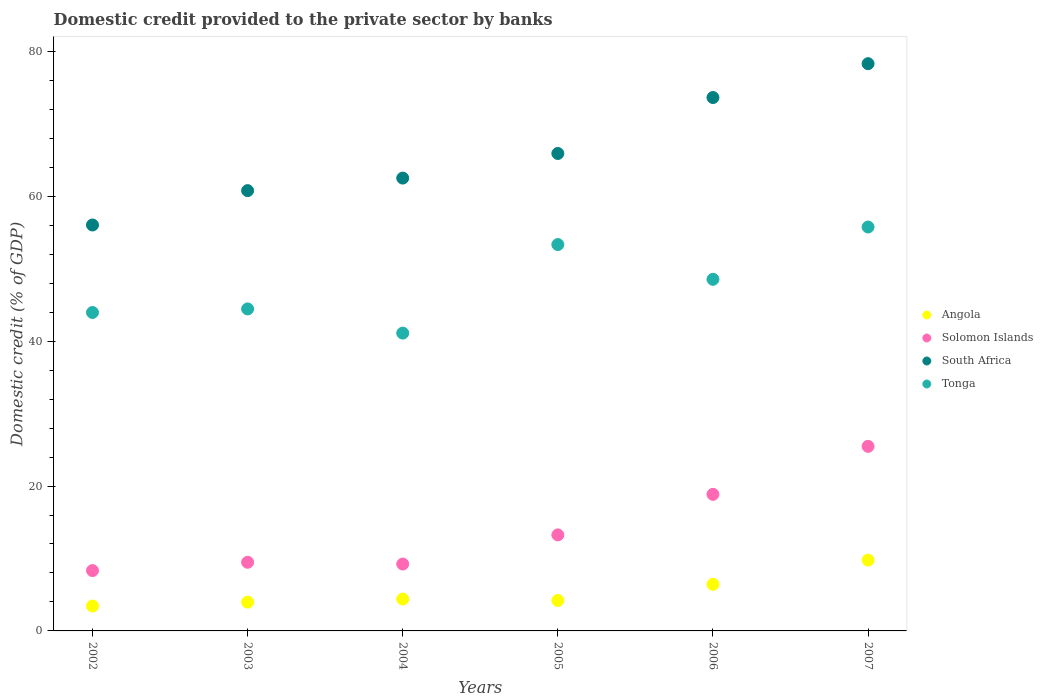Is the number of dotlines equal to the number of legend labels?
Keep it short and to the point. Yes. What is the domestic credit provided to the private sector by banks in Tonga in 2002?
Ensure brevity in your answer.  43.95. Across all years, what is the maximum domestic credit provided to the private sector by banks in Angola?
Offer a very short reply. 9.77. Across all years, what is the minimum domestic credit provided to the private sector by banks in Tonga?
Your answer should be compact. 41.11. In which year was the domestic credit provided to the private sector by banks in Angola minimum?
Offer a terse response. 2002. What is the total domestic credit provided to the private sector by banks in Solomon Islands in the graph?
Give a very brief answer. 84.62. What is the difference between the domestic credit provided to the private sector by banks in South Africa in 2006 and that in 2007?
Offer a very short reply. -4.67. What is the difference between the domestic credit provided to the private sector by banks in Angola in 2004 and the domestic credit provided to the private sector by banks in South Africa in 2005?
Offer a terse response. -61.5. What is the average domestic credit provided to the private sector by banks in Angola per year?
Your answer should be very brief. 5.37. In the year 2002, what is the difference between the domestic credit provided to the private sector by banks in Solomon Islands and domestic credit provided to the private sector by banks in Angola?
Your answer should be very brief. 4.89. What is the ratio of the domestic credit provided to the private sector by banks in Angola in 2004 to that in 2007?
Keep it short and to the point. 0.45. Is the difference between the domestic credit provided to the private sector by banks in Solomon Islands in 2002 and 2005 greater than the difference between the domestic credit provided to the private sector by banks in Angola in 2002 and 2005?
Give a very brief answer. No. What is the difference between the highest and the second highest domestic credit provided to the private sector by banks in South Africa?
Keep it short and to the point. 4.67. What is the difference between the highest and the lowest domestic credit provided to the private sector by banks in South Africa?
Your answer should be very brief. 22.26. In how many years, is the domestic credit provided to the private sector by banks in South Africa greater than the average domestic credit provided to the private sector by banks in South Africa taken over all years?
Offer a terse response. 2. Is the sum of the domestic credit provided to the private sector by banks in South Africa in 2005 and 2007 greater than the maximum domestic credit provided to the private sector by banks in Tonga across all years?
Keep it short and to the point. Yes. Is it the case that in every year, the sum of the domestic credit provided to the private sector by banks in Tonga and domestic credit provided to the private sector by banks in South Africa  is greater than the domestic credit provided to the private sector by banks in Solomon Islands?
Your response must be concise. Yes. Does the domestic credit provided to the private sector by banks in South Africa monotonically increase over the years?
Your answer should be compact. Yes. Is the domestic credit provided to the private sector by banks in Solomon Islands strictly greater than the domestic credit provided to the private sector by banks in Tonga over the years?
Provide a short and direct response. No. How many dotlines are there?
Provide a succinct answer. 4. Does the graph contain any zero values?
Give a very brief answer. No. Does the graph contain grids?
Your answer should be very brief. No. How many legend labels are there?
Offer a very short reply. 4. How are the legend labels stacked?
Provide a succinct answer. Vertical. What is the title of the graph?
Ensure brevity in your answer.  Domestic credit provided to the private sector by banks. What is the label or title of the Y-axis?
Keep it short and to the point. Domestic credit (% of GDP). What is the Domestic credit (% of GDP) of Angola in 2002?
Keep it short and to the point. 3.44. What is the Domestic credit (% of GDP) of Solomon Islands in 2002?
Provide a short and direct response. 8.33. What is the Domestic credit (% of GDP) of South Africa in 2002?
Offer a very short reply. 56.03. What is the Domestic credit (% of GDP) in Tonga in 2002?
Give a very brief answer. 43.95. What is the Domestic credit (% of GDP) in Angola in 2003?
Provide a succinct answer. 3.98. What is the Domestic credit (% of GDP) in Solomon Islands in 2003?
Your response must be concise. 9.48. What is the Domestic credit (% of GDP) of South Africa in 2003?
Your response must be concise. 60.77. What is the Domestic credit (% of GDP) of Tonga in 2003?
Offer a terse response. 44.44. What is the Domestic credit (% of GDP) in Angola in 2004?
Ensure brevity in your answer.  4.4. What is the Domestic credit (% of GDP) of Solomon Islands in 2004?
Offer a terse response. 9.23. What is the Domestic credit (% of GDP) in South Africa in 2004?
Offer a terse response. 62.5. What is the Domestic credit (% of GDP) of Tonga in 2004?
Your answer should be very brief. 41.11. What is the Domestic credit (% of GDP) of Angola in 2005?
Keep it short and to the point. 4.2. What is the Domestic credit (% of GDP) in Solomon Islands in 2005?
Provide a succinct answer. 13.25. What is the Domestic credit (% of GDP) of South Africa in 2005?
Give a very brief answer. 65.9. What is the Domestic credit (% of GDP) in Tonga in 2005?
Give a very brief answer. 53.33. What is the Domestic credit (% of GDP) in Angola in 2006?
Your answer should be compact. 6.43. What is the Domestic credit (% of GDP) in Solomon Islands in 2006?
Your answer should be compact. 18.85. What is the Domestic credit (% of GDP) of South Africa in 2006?
Your answer should be compact. 73.62. What is the Domestic credit (% of GDP) in Tonga in 2006?
Provide a short and direct response. 48.53. What is the Domestic credit (% of GDP) in Angola in 2007?
Your answer should be compact. 9.77. What is the Domestic credit (% of GDP) in Solomon Islands in 2007?
Your answer should be compact. 25.48. What is the Domestic credit (% of GDP) in South Africa in 2007?
Offer a very short reply. 78.29. What is the Domestic credit (% of GDP) in Tonga in 2007?
Provide a succinct answer. 55.75. Across all years, what is the maximum Domestic credit (% of GDP) of Angola?
Provide a short and direct response. 9.77. Across all years, what is the maximum Domestic credit (% of GDP) of Solomon Islands?
Provide a succinct answer. 25.48. Across all years, what is the maximum Domestic credit (% of GDP) of South Africa?
Your response must be concise. 78.29. Across all years, what is the maximum Domestic credit (% of GDP) of Tonga?
Keep it short and to the point. 55.75. Across all years, what is the minimum Domestic credit (% of GDP) in Angola?
Ensure brevity in your answer.  3.44. Across all years, what is the minimum Domestic credit (% of GDP) in Solomon Islands?
Offer a terse response. 8.33. Across all years, what is the minimum Domestic credit (% of GDP) in South Africa?
Ensure brevity in your answer.  56.03. Across all years, what is the minimum Domestic credit (% of GDP) of Tonga?
Keep it short and to the point. 41.11. What is the total Domestic credit (% of GDP) in Angola in the graph?
Keep it short and to the point. 32.21. What is the total Domestic credit (% of GDP) in Solomon Islands in the graph?
Keep it short and to the point. 84.62. What is the total Domestic credit (% of GDP) of South Africa in the graph?
Provide a short and direct response. 397.13. What is the total Domestic credit (% of GDP) of Tonga in the graph?
Your response must be concise. 287.11. What is the difference between the Domestic credit (% of GDP) of Angola in 2002 and that in 2003?
Offer a terse response. -0.54. What is the difference between the Domestic credit (% of GDP) of Solomon Islands in 2002 and that in 2003?
Your answer should be very brief. -1.15. What is the difference between the Domestic credit (% of GDP) in South Africa in 2002 and that in 2003?
Make the answer very short. -4.74. What is the difference between the Domestic credit (% of GDP) of Tonga in 2002 and that in 2003?
Provide a succinct answer. -0.49. What is the difference between the Domestic credit (% of GDP) of Angola in 2002 and that in 2004?
Your response must be concise. -0.96. What is the difference between the Domestic credit (% of GDP) of Solomon Islands in 2002 and that in 2004?
Ensure brevity in your answer.  -0.9. What is the difference between the Domestic credit (% of GDP) in South Africa in 2002 and that in 2004?
Your response must be concise. -6.47. What is the difference between the Domestic credit (% of GDP) of Tonga in 2002 and that in 2004?
Keep it short and to the point. 2.85. What is the difference between the Domestic credit (% of GDP) in Angola in 2002 and that in 2005?
Your answer should be very brief. -0.77. What is the difference between the Domestic credit (% of GDP) in Solomon Islands in 2002 and that in 2005?
Ensure brevity in your answer.  -4.93. What is the difference between the Domestic credit (% of GDP) in South Africa in 2002 and that in 2005?
Your answer should be very brief. -9.87. What is the difference between the Domestic credit (% of GDP) in Tonga in 2002 and that in 2005?
Offer a very short reply. -9.38. What is the difference between the Domestic credit (% of GDP) of Angola in 2002 and that in 2006?
Give a very brief answer. -2.99. What is the difference between the Domestic credit (% of GDP) of Solomon Islands in 2002 and that in 2006?
Your answer should be very brief. -10.52. What is the difference between the Domestic credit (% of GDP) in South Africa in 2002 and that in 2006?
Ensure brevity in your answer.  -17.59. What is the difference between the Domestic credit (% of GDP) in Tonga in 2002 and that in 2006?
Your answer should be compact. -4.58. What is the difference between the Domestic credit (% of GDP) of Angola in 2002 and that in 2007?
Offer a terse response. -6.34. What is the difference between the Domestic credit (% of GDP) in Solomon Islands in 2002 and that in 2007?
Offer a terse response. -17.15. What is the difference between the Domestic credit (% of GDP) of South Africa in 2002 and that in 2007?
Ensure brevity in your answer.  -22.26. What is the difference between the Domestic credit (% of GDP) in Tonga in 2002 and that in 2007?
Offer a terse response. -11.8. What is the difference between the Domestic credit (% of GDP) of Angola in 2003 and that in 2004?
Offer a very short reply. -0.42. What is the difference between the Domestic credit (% of GDP) of Solomon Islands in 2003 and that in 2004?
Your answer should be compact. 0.25. What is the difference between the Domestic credit (% of GDP) of South Africa in 2003 and that in 2004?
Provide a succinct answer. -1.73. What is the difference between the Domestic credit (% of GDP) of Tonga in 2003 and that in 2004?
Offer a very short reply. 3.34. What is the difference between the Domestic credit (% of GDP) in Angola in 2003 and that in 2005?
Your answer should be very brief. -0.23. What is the difference between the Domestic credit (% of GDP) in Solomon Islands in 2003 and that in 2005?
Ensure brevity in your answer.  -3.78. What is the difference between the Domestic credit (% of GDP) of South Africa in 2003 and that in 2005?
Provide a succinct answer. -5.13. What is the difference between the Domestic credit (% of GDP) of Tonga in 2003 and that in 2005?
Offer a terse response. -8.88. What is the difference between the Domestic credit (% of GDP) in Angola in 2003 and that in 2006?
Ensure brevity in your answer.  -2.45. What is the difference between the Domestic credit (% of GDP) of Solomon Islands in 2003 and that in 2006?
Give a very brief answer. -9.37. What is the difference between the Domestic credit (% of GDP) of South Africa in 2003 and that in 2006?
Ensure brevity in your answer.  -12.85. What is the difference between the Domestic credit (% of GDP) of Tonga in 2003 and that in 2006?
Offer a very short reply. -4.09. What is the difference between the Domestic credit (% of GDP) in Angola in 2003 and that in 2007?
Provide a short and direct response. -5.8. What is the difference between the Domestic credit (% of GDP) in Solomon Islands in 2003 and that in 2007?
Make the answer very short. -16. What is the difference between the Domestic credit (% of GDP) in South Africa in 2003 and that in 2007?
Offer a terse response. -17.52. What is the difference between the Domestic credit (% of GDP) in Tonga in 2003 and that in 2007?
Provide a short and direct response. -11.31. What is the difference between the Domestic credit (% of GDP) of Angola in 2004 and that in 2005?
Your response must be concise. 0.2. What is the difference between the Domestic credit (% of GDP) in Solomon Islands in 2004 and that in 2005?
Keep it short and to the point. -4.02. What is the difference between the Domestic credit (% of GDP) of South Africa in 2004 and that in 2005?
Offer a very short reply. -3.4. What is the difference between the Domestic credit (% of GDP) of Tonga in 2004 and that in 2005?
Give a very brief answer. -12.22. What is the difference between the Domestic credit (% of GDP) of Angola in 2004 and that in 2006?
Give a very brief answer. -2.03. What is the difference between the Domestic credit (% of GDP) of Solomon Islands in 2004 and that in 2006?
Give a very brief answer. -9.62. What is the difference between the Domestic credit (% of GDP) of South Africa in 2004 and that in 2006?
Your answer should be very brief. -11.12. What is the difference between the Domestic credit (% of GDP) in Tonga in 2004 and that in 2006?
Offer a terse response. -7.42. What is the difference between the Domestic credit (% of GDP) in Angola in 2004 and that in 2007?
Make the answer very short. -5.38. What is the difference between the Domestic credit (% of GDP) of Solomon Islands in 2004 and that in 2007?
Provide a succinct answer. -16.25. What is the difference between the Domestic credit (% of GDP) in South Africa in 2004 and that in 2007?
Offer a very short reply. -15.79. What is the difference between the Domestic credit (% of GDP) in Tonga in 2004 and that in 2007?
Make the answer very short. -14.64. What is the difference between the Domestic credit (% of GDP) in Angola in 2005 and that in 2006?
Keep it short and to the point. -2.22. What is the difference between the Domestic credit (% of GDP) in Solomon Islands in 2005 and that in 2006?
Your response must be concise. -5.6. What is the difference between the Domestic credit (% of GDP) of South Africa in 2005 and that in 2006?
Your response must be concise. -7.72. What is the difference between the Domestic credit (% of GDP) of Tonga in 2005 and that in 2006?
Provide a short and direct response. 4.8. What is the difference between the Domestic credit (% of GDP) in Angola in 2005 and that in 2007?
Give a very brief answer. -5.57. What is the difference between the Domestic credit (% of GDP) of Solomon Islands in 2005 and that in 2007?
Provide a short and direct response. -12.22. What is the difference between the Domestic credit (% of GDP) of South Africa in 2005 and that in 2007?
Offer a terse response. -12.39. What is the difference between the Domestic credit (% of GDP) in Tonga in 2005 and that in 2007?
Keep it short and to the point. -2.42. What is the difference between the Domestic credit (% of GDP) in Angola in 2006 and that in 2007?
Provide a succinct answer. -3.35. What is the difference between the Domestic credit (% of GDP) of Solomon Islands in 2006 and that in 2007?
Your response must be concise. -6.63. What is the difference between the Domestic credit (% of GDP) of South Africa in 2006 and that in 2007?
Your answer should be compact. -4.67. What is the difference between the Domestic credit (% of GDP) of Tonga in 2006 and that in 2007?
Keep it short and to the point. -7.22. What is the difference between the Domestic credit (% of GDP) of Angola in 2002 and the Domestic credit (% of GDP) of Solomon Islands in 2003?
Your response must be concise. -6.04. What is the difference between the Domestic credit (% of GDP) in Angola in 2002 and the Domestic credit (% of GDP) in South Africa in 2003?
Provide a succinct answer. -57.34. What is the difference between the Domestic credit (% of GDP) of Angola in 2002 and the Domestic credit (% of GDP) of Tonga in 2003?
Make the answer very short. -41.01. What is the difference between the Domestic credit (% of GDP) in Solomon Islands in 2002 and the Domestic credit (% of GDP) in South Africa in 2003?
Keep it short and to the point. -52.44. What is the difference between the Domestic credit (% of GDP) in Solomon Islands in 2002 and the Domestic credit (% of GDP) in Tonga in 2003?
Keep it short and to the point. -36.12. What is the difference between the Domestic credit (% of GDP) in South Africa in 2002 and the Domestic credit (% of GDP) in Tonga in 2003?
Provide a succinct answer. 11.59. What is the difference between the Domestic credit (% of GDP) of Angola in 2002 and the Domestic credit (% of GDP) of Solomon Islands in 2004?
Provide a succinct answer. -5.8. What is the difference between the Domestic credit (% of GDP) in Angola in 2002 and the Domestic credit (% of GDP) in South Africa in 2004?
Offer a very short reply. -59.07. What is the difference between the Domestic credit (% of GDP) in Angola in 2002 and the Domestic credit (% of GDP) in Tonga in 2004?
Give a very brief answer. -37.67. What is the difference between the Domestic credit (% of GDP) in Solomon Islands in 2002 and the Domestic credit (% of GDP) in South Africa in 2004?
Offer a very short reply. -54.18. What is the difference between the Domestic credit (% of GDP) of Solomon Islands in 2002 and the Domestic credit (% of GDP) of Tonga in 2004?
Give a very brief answer. -32.78. What is the difference between the Domestic credit (% of GDP) in South Africa in 2002 and the Domestic credit (% of GDP) in Tonga in 2004?
Ensure brevity in your answer.  14.92. What is the difference between the Domestic credit (% of GDP) in Angola in 2002 and the Domestic credit (% of GDP) in Solomon Islands in 2005?
Offer a terse response. -9.82. What is the difference between the Domestic credit (% of GDP) of Angola in 2002 and the Domestic credit (% of GDP) of South Africa in 2005?
Give a very brief answer. -62.47. What is the difference between the Domestic credit (% of GDP) in Angola in 2002 and the Domestic credit (% of GDP) in Tonga in 2005?
Offer a very short reply. -49.89. What is the difference between the Domestic credit (% of GDP) of Solomon Islands in 2002 and the Domestic credit (% of GDP) of South Africa in 2005?
Your response must be concise. -57.57. What is the difference between the Domestic credit (% of GDP) in Solomon Islands in 2002 and the Domestic credit (% of GDP) in Tonga in 2005?
Offer a terse response. -45. What is the difference between the Domestic credit (% of GDP) of South Africa in 2002 and the Domestic credit (% of GDP) of Tonga in 2005?
Your answer should be very brief. 2.7. What is the difference between the Domestic credit (% of GDP) of Angola in 2002 and the Domestic credit (% of GDP) of Solomon Islands in 2006?
Keep it short and to the point. -15.42. What is the difference between the Domestic credit (% of GDP) in Angola in 2002 and the Domestic credit (% of GDP) in South Africa in 2006?
Your answer should be compact. -70.19. What is the difference between the Domestic credit (% of GDP) of Angola in 2002 and the Domestic credit (% of GDP) of Tonga in 2006?
Offer a very short reply. -45.1. What is the difference between the Domestic credit (% of GDP) in Solomon Islands in 2002 and the Domestic credit (% of GDP) in South Africa in 2006?
Ensure brevity in your answer.  -65.3. What is the difference between the Domestic credit (% of GDP) of Solomon Islands in 2002 and the Domestic credit (% of GDP) of Tonga in 2006?
Provide a short and direct response. -40.2. What is the difference between the Domestic credit (% of GDP) of South Africa in 2002 and the Domestic credit (% of GDP) of Tonga in 2006?
Give a very brief answer. 7.5. What is the difference between the Domestic credit (% of GDP) of Angola in 2002 and the Domestic credit (% of GDP) of Solomon Islands in 2007?
Your response must be concise. -22.04. What is the difference between the Domestic credit (% of GDP) of Angola in 2002 and the Domestic credit (% of GDP) of South Africa in 2007?
Your answer should be compact. -74.86. What is the difference between the Domestic credit (% of GDP) in Angola in 2002 and the Domestic credit (% of GDP) in Tonga in 2007?
Give a very brief answer. -52.32. What is the difference between the Domestic credit (% of GDP) in Solomon Islands in 2002 and the Domestic credit (% of GDP) in South Africa in 2007?
Your answer should be very brief. -69.97. What is the difference between the Domestic credit (% of GDP) of Solomon Islands in 2002 and the Domestic credit (% of GDP) of Tonga in 2007?
Your answer should be very brief. -47.42. What is the difference between the Domestic credit (% of GDP) of South Africa in 2002 and the Domestic credit (% of GDP) of Tonga in 2007?
Ensure brevity in your answer.  0.28. What is the difference between the Domestic credit (% of GDP) in Angola in 2003 and the Domestic credit (% of GDP) in Solomon Islands in 2004?
Your answer should be compact. -5.26. What is the difference between the Domestic credit (% of GDP) in Angola in 2003 and the Domestic credit (% of GDP) in South Africa in 2004?
Your answer should be compact. -58.53. What is the difference between the Domestic credit (% of GDP) in Angola in 2003 and the Domestic credit (% of GDP) in Tonga in 2004?
Offer a very short reply. -37.13. What is the difference between the Domestic credit (% of GDP) in Solomon Islands in 2003 and the Domestic credit (% of GDP) in South Africa in 2004?
Give a very brief answer. -53.03. What is the difference between the Domestic credit (% of GDP) in Solomon Islands in 2003 and the Domestic credit (% of GDP) in Tonga in 2004?
Your answer should be very brief. -31.63. What is the difference between the Domestic credit (% of GDP) in South Africa in 2003 and the Domestic credit (% of GDP) in Tonga in 2004?
Provide a succinct answer. 19.67. What is the difference between the Domestic credit (% of GDP) in Angola in 2003 and the Domestic credit (% of GDP) in Solomon Islands in 2005?
Ensure brevity in your answer.  -9.28. What is the difference between the Domestic credit (% of GDP) of Angola in 2003 and the Domestic credit (% of GDP) of South Africa in 2005?
Offer a very short reply. -61.93. What is the difference between the Domestic credit (% of GDP) of Angola in 2003 and the Domestic credit (% of GDP) of Tonga in 2005?
Provide a succinct answer. -49.35. What is the difference between the Domestic credit (% of GDP) of Solomon Islands in 2003 and the Domestic credit (% of GDP) of South Africa in 2005?
Ensure brevity in your answer.  -56.43. What is the difference between the Domestic credit (% of GDP) in Solomon Islands in 2003 and the Domestic credit (% of GDP) in Tonga in 2005?
Offer a terse response. -43.85. What is the difference between the Domestic credit (% of GDP) of South Africa in 2003 and the Domestic credit (% of GDP) of Tonga in 2005?
Provide a succinct answer. 7.44. What is the difference between the Domestic credit (% of GDP) in Angola in 2003 and the Domestic credit (% of GDP) in Solomon Islands in 2006?
Offer a terse response. -14.88. What is the difference between the Domestic credit (% of GDP) of Angola in 2003 and the Domestic credit (% of GDP) of South Africa in 2006?
Offer a very short reply. -69.65. What is the difference between the Domestic credit (% of GDP) of Angola in 2003 and the Domestic credit (% of GDP) of Tonga in 2006?
Offer a terse response. -44.55. What is the difference between the Domestic credit (% of GDP) in Solomon Islands in 2003 and the Domestic credit (% of GDP) in South Africa in 2006?
Offer a terse response. -64.15. What is the difference between the Domestic credit (% of GDP) in Solomon Islands in 2003 and the Domestic credit (% of GDP) in Tonga in 2006?
Provide a succinct answer. -39.05. What is the difference between the Domestic credit (% of GDP) in South Africa in 2003 and the Domestic credit (% of GDP) in Tonga in 2006?
Your answer should be very brief. 12.24. What is the difference between the Domestic credit (% of GDP) in Angola in 2003 and the Domestic credit (% of GDP) in Solomon Islands in 2007?
Offer a very short reply. -21.5. What is the difference between the Domestic credit (% of GDP) in Angola in 2003 and the Domestic credit (% of GDP) in South Africa in 2007?
Make the answer very short. -74.32. What is the difference between the Domestic credit (% of GDP) of Angola in 2003 and the Domestic credit (% of GDP) of Tonga in 2007?
Your answer should be very brief. -51.77. What is the difference between the Domestic credit (% of GDP) of Solomon Islands in 2003 and the Domestic credit (% of GDP) of South Africa in 2007?
Ensure brevity in your answer.  -68.82. What is the difference between the Domestic credit (% of GDP) in Solomon Islands in 2003 and the Domestic credit (% of GDP) in Tonga in 2007?
Provide a succinct answer. -46.27. What is the difference between the Domestic credit (% of GDP) in South Africa in 2003 and the Domestic credit (% of GDP) in Tonga in 2007?
Ensure brevity in your answer.  5.02. What is the difference between the Domestic credit (% of GDP) in Angola in 2004 and the Domestic credit (% of GDP) in Solomon Islands in 2005?
Your answer should be very brief. -8.86. What is the difference between the Domestic credit (% of GDP) of Angola in 2004 and the Domestic credit (% of GDP) of South Africa in 2005?
Provide a short and direct response. -61.5. What is the difference between the Domestic credit (% of GDP) in Angola in 2004 and the Domestic credit (% of GDP) in Tonga in 2005?
Give a very brief answer. -48.93. What is the difference between the Domestic credit (% of GDP) of Solomon Islands in 2004 and the Domestic credit (% of GDP) of South Africa in 2005?
Offer a terse response. -56.67. What is the difference between the Domestic credit (% of GDP) in Solomon Islands in 2004 and the Domestic credit (% of GDP) in Tonga in 2005?
Your answer should be very brief. -44.1. What is the difference between the Domestic credit (% of GDP) in South Africa in 2004 and the Domestic credit (% of GDP) in Tonga in 2005?
Make the answer very short. 9.18. What is the difference between the Domestic credit (% of GDP) of Angola in 2004 and the Domestic credit (% of GDP) of Solomon Islands in 2006?
Provide a short and direct response. -14.45. What is the difference between the Domestic credit (% of GDP) in Angola in 2004 and the Domestic credit (% of GDP) in South Africa in 2006?
Provide a succinct answer. -69.23. What is the difference between the Domestic credit (% of GDP) of Angola in 2004 and the Domestic credit (% of GDP) of Tonga in 2006?
Make the answer very short. -44.13. What is the difference between the Domestic credit (% of GDP) of Solomon Islands in 2004 and the Domestic credit (% of GDP) of South Africa in 2006?
Your answer should be compact. -64.39. What is the difference between the Domestic credit (% of GDP) in Solomon Islands in 2004 and the Domestic credit (% of GDP) in Tonga in 2006?
Keep it short and to the point. -39.3. What is the difference between the Domestic credit (% of GDP) in South Africa in 2004 and the Domestic credit (% of GDP) in Tonga in 2006?
Your answer should be compact. 13.97. What is the difference between the Domestic credit (% of GDP) of Angola in 2004 and the Domestic credit (% of GDP) of Solomon Islands in 2007?
Provide a short and direct response. -21.08. What is the difference between the Domestic credit (% of GDP) of Angola in 2004 and the Domestic credit (% of GDP) of South Africa in 2007?
Provide a short and direct response. -73.9. What is the difference between the Domestic credit (% of GDP) of Angola in 2004 and the Domestic credit (% of GDP) of Tonga in 2007?
Offer a very short reply. -51.35. What is the difference between the Domestic credit (% of GDP) of Solomon Islands in 2004 and the Domestic credit (% of GDP) of South Africa in 2007?
Give a very brief answer. -69.06. What is the difference between the Domestic credit (% of GDP) in Solomon Islands in 2004 and the Domestic credit (% of GDP) in Tonga in 2007?
Your answer should be compact. -46.52. What is the difference between the Domestic credit (% of GDP) in South Africa in 2004 and the Domestic credit (% of GDP) in Tonga in 2007?
Offer a terse response. 6.75. What is the difference between the Domestic credit (% of GDP) in Angola in 2005 and the Domestic credit (% of GDP) in Solomon Islands in 2006?
Keep it short and to the point. -14.65. What is the difference between the Domestic credit (% of GDP) of Angola in 2005 and the Domestic credit (% of GDP) of South Africa in 2006?
Your response must be concise. -69.42. What is the difference between the Domestic credit (% of GDP) of Angola in 2005 and the Domestic credit (% of GDP) of Tonga in 2006?
Ensure brevity in your answer.  -44.33. What is the difference between the Domestic credit (% of GDP) in Solomon Islands in 2005 and the Domestic credit (% of GDP) in South Africa in 2006?
Provide a short and direct response. -60.37. What is the difference between the Domestic credit (% of GDP) of Solomon Islands in 2005 and the Domestic credit (% of GDP) of Tonga in 2006?
Ensure brevity in your answer.  -35.28. What is the difference between the Domestic credit (% of GDP) of South Africa in 2005 and the Domestic credit (% of GDP) of Tonga in 2006?
Keep it short and to the point. 17.37. What is the difference between the Domestic credit (% of GDP) of Angola in 2005 and the Domestic credit (% of GDP) of Solomon Islands in 2007?
Ensure brevity in your answer.  -21.27. What is the difference between the Domestic credit (% of GDP) of Angola in 2005 and the Domestic credit (% of GDP) of South Africa in 2007?
Make the answer very short. -74.09. What is the difference between the Domestic credit (% of GDP) in Angola in 2005 and the Domestic credit (% of GDP) in Tonga in 2007?
Your response must be concise. -51.55. What is the difference between the Domestic credit (% of GDP) of Solomon Islands in 2005 and the Domestic credit (% of GDP) of South Africa in 2007?
Offer a very short reply. -65.04. What is the difference between the Domestic credit (% of GDP) of Solomon Islands in 2005 and the Domestic credit (% of GDP) of Tonga in 2007?
Your answer should be compact. -42.5. What is the difference between the Domestic credit (% of GDP) in South Africa in 2005 and the Domestic credit (% of GDP) in Tonga in 2007?
Offer a very short reply. 10.15. What is the difference between the Domestic credit (% of GDP) in Angola in 2006 and the Domestic credit (% of GDP) in Solomon Islands in 2007?
Give a very brief answer. -19.05. What is the difference between the Domestic credit (% of GDP) in Angola in 2006 and the Domestic credit (% of GDP) in South Africa in 2007?
Your answer should be compact. -71.87. What is the difference between the Domestic credit (% of GDP) of Angola in 2006 and the Domestic credit (% of GDP) of Tonga in 2007?
Give a very brief answer. -49.32. What is the difference between the Domestic credit (% of GDP) in Solomon Islands in 2006 and the Domestic credit (% of GDP) in South Africa in 2007?
Provide a succinct answer. -59.44. What is the difference between the Domestic credit (% of GDP) in Solomon Islands in 2006 and the Domestic credit (% of GDP) in Tonga in 2007?
Your answer should be very brief. -36.9. What is the difference between the Domestic credit (% of GDP) of South Africa in 2006 and the Domestic credit (% of GDP) of Tonga in 2007?
Your answer should be very brief. 17.87. What is the average Domestic credit (% of GDP) in Angola per year?
Provide a short and direct response. 5.37. What is the average Domestic credit (% of GDP) in Solomon Islands per year?
Offer a terse response. 14.1. What is the average Domestic credit (% of GDP) of South Africa per year?
Your answer should be very brief. 66.19. What is the average Domestic credit (% of GDP) of Tonga per year?
Provide a short and direct response. 47.85. In the year 2002, what is the difference between the Domestic credit (% of GDP) in Angola and Domestic credit (% of GDP) in Solomon Islands?
Provide a succinct answer. -4.89. In the year 2002, what is the difference between the Domestic credit (% of GDP) of Angola and Domestic credit (% of GDP) of South Africa?
Offer a terse response. -52.6. In the year 2002, what is the difference between the Domestic credit (% of GDP) in Angola and Domestic credit (% of GDP) in Tonga?
Keep it short and to the point. -40.52. In the year 2002, what is the difference between the Domestic credit (% of GDP) of Solomon Islands and Domestic credit (% of GDP) of South Africa?
Provide a short and direct response. -47.7. In the year 2002, what is the difference between the Domestic credit (% of GDP) in Solomon Islands and Domestic credit (% of GDP) in Tonga?
Provide a short and direct response. -35.63. In the year 2002, what is the difference between the Domestic credit (% of GDP) in South Africa and Domestic credit (% of GDP) in Tonga?
Your answer should be compact. 12.08. In the year 2003, what is the difference between the Domestic credit (% of GDP) of Angola and Domestic credit (% of GDP) of Solomon Islands?
Make the answer very short. -5.5. In the year 2003, what is the difference between the Domestic credit (% of GDP) in Angola and Domestic credit (% of GDP) in South Africa?
Offer a very short reply. -56.8. In the year 2003, what is the difference between the Domestic credit (% of GDP) in Angola and Domestic credit (% of GDP) in Tonga?
Your answer should be very brief. -40.47. In the year 2003, what is the difference between the Domestic credit (% of GDP) of Solomon Islands and Domestic credit (% of GDP) of South Africa?
Provide a short and direct response. -51.3. In the year 2003, what is the difference between the Domestic credit (% of GDP) of Solomon Islands and Domestic credit (% of GDP) of Tonga?
Your answer should be very brief. -34.97. In the year 2003, what is the difference between the Domestic credit (% of GDP) in South Africa and Domestic credit (% of GDP) in Tonga?
Offer a terse response. 16.33. In the year 2004, what is the difference between the Domestic credit (% of GDP) of Angola and Domestic credit (% of GDP) of Solomon Islands?
Provide a short and direct response. -4.83. In the year 2004, what is the difference between the Domestic credit (% of GDP) in Angola and Domestic credit (% of GDP) in South Africa?
Your answer should be very brief. -58.11. In the year 2004, what is the difference between the Domestic credit (% of GDP) in Angola and Domestic credit (% of GDP) in Tonga?
Give a very brief answer. -36.71. In the year 2004, what is the difference between the Domestic credit (% of GDP) of Solomon Islands and Domestic credit (% of GDP) of South Africa?
Keep it short and to the point. -53.27. In the year 2004, what is the difference between the Domestic credit (% of GDP) in Solomon Islands and Domestic credit (% of GDP) in Tonga?
Offer a terse response. -31.87. In the year 2004, what is the difference between the Domestic credit (% of GDP) in South Africa and Domestic credit (% of GDP) in Tonga?
Provide a short and direct response. 21.4. In the year 2005, what is the difference between the Domestic credit (% of GDP) of Angola and Domestic credit (% of GDP) of Solomon Islands?
Provide a short and direct response. -9.05. In the year 2005, what is the difference between the Domestic credit (% of GDP) of Angola and Domestic credit (% of GDP) of South Africa?
Offer a very short reply. -61.7. In the year 2005, what is the difference between the Domestic credit (% of GDP) of Angola and Domestic credit (% of GDP) of Tonga?
Make the answer very short. -49.13. In the year 2005, what is the difference between the Domestic credit (% of GDP) in Solomon Islands and Domestic credit (% of GDP) in South Africa?
Your answer should be compact. -52.65. In the year 2005, what is the difference between the Domestic credit (% of GDP) of Solomon Islands and Domestic credit (% of GDP) of Tonga?
Offer a very short reply. -40.07. In the year 2005, what is the difference between the Domestic credit (% of GDP) in South Africa and Domestic credit (% of GDP) in Tonga?
Ensure brevity in your answer.  12.57. In the year 2006, what is the difference between the Domestic credit (% of GDP) in Angola and Domestic credit (% of GDP) in Solomon Islands?
Keep it short and to the point. -12.43. In the year 2006, what is the difference between the Domestic credit (% of GDP) of Angola and Domestic credit (% of GDP) of South Africa?
Provide a short and direct response. -67.2. In the year 2006, what is the difference between the Domestic credit (% of GDP) in Angola and Domestic credit (% of GDP) in Tonga?
Offer a very short reply. -42.11. In the year 2006, what is the difference between the Domestic credit (% of GDP) in Solomon Islands and Domestic credit (% of GDP) in South Africa?
Ensure brevity in your answer.  -54.77. In the year 2006, what is the difference between the Domestic credit (% of GDP) of Solomon Islands and Domestic credit (% of GDP) of Tonga?
Keep it short and to the point. -29.68. In the year 2006, what is the difference between the Domestic credit (% of GDP) in South Africa and Domestic credit (% of GDP) in Tonga?
Ensure brevity in your answer.  25.09. In the year 2007, what is the difference between the Domestic credit (% of GDP) of Angola and Domestic credit (% of GDP) of Solomon Islands?
Your answer should be very brief. -15.7. In the year 2007, what is the difference between the Domestic credit (% of GDP) in Angola and Domestic credit (% of GDP) in South Africa?
Keep it short and to the point. -68.52. In the year 2007, what is the difference between the Domestic credit (% of GDP) in Angola and Domestic credit (% of GDP) in Tonga?
Provide a short and direct response. -45.98. In the year 2007, what is the difference between the Domestic credit (% of GDP) in Solomon Islands and Domestic credit (% of GDP) in South Africa?
Keep it short and to the point. -52.82. In the year 2007, what is the difference between the Domestic credit (% of GDP) of Solomon Islands and Domestic credit (% of GDP) of Tonga?
Your answer should be compact. -30.27. In the year 2007, what is the difference between the Domestic credit (% of GDP) of South Africa and Domestic credit (% of GDP) of Tonga?
Ensure brevity in your answer.  22.54. What is the ratio of the Domestic credit (% of GDP) in Angola in 2002 to that in 2003?
Keep it short and to the point. 0.86. What is the ratio of the Domestic credit (% of GDP) of Solomon Islands in 2002 to that in 2003?
Your answer should be compact. 0.88. What is the ratio of the Domestic credit (% of GDP) of South Africa in 2002 to that in 2003?
Offer a very short reply. 0.92. What is the ratio of the Domestic credit (% of GDP) in Tonga in 2002 to that in 2003?
Offer a terse response. 0.99. What is the ratio of the Domestic credit (% of GDP) in Angola in 2002 to that in 2004?
Offer a terse response. 0.78. What is the ratio of the Domestic credit (% of GDP) in Solomon Islands in 2002 to that in 2004?
Your answer should be very brief. 0.9. What is the ratio of the Domestic credit (% of GDP) of South Africa in 2002 to that in 2004?
Ensure brevity in your answer.  0.9. What is the ratio of the Domestic credit (% of GDP) of Tonga in 2002 to that in 2004?
Offer a terse response. 1.07. What is the ratio of the Domestic credit (% of GDP) in Angola in 2002 to that in 2005?
Offer a very short reply. 0.82. What is the ratio of the Domestic credit (% of GDP) of Solomon Islands in 2002 to that in 2005?
Offer a very short reply. 0.63. What is the ratio of the Domestic credit (% of GDP) in South Africa in 2002 to that in 2005?
Provide a succinct answer. 0.85. What is the ratio of the Domestic credit (% of GDP) in Tonga in 2002 to that in 2005?
Offer a very short reply. 0.82. What is the ratio of the Domestic credit (% of GDP) in Angola in 2002 to that in 2006?
Offer a very short reply. 0.53. What is the ratio of the Domestic credit (% of GDP) of Solomon Islands in 2002 to that in 2006?
Ensure brevity in your answer.  0.44. What is the ratio of the Domestic credit (% of GDP) in South Africa in 2002 to that in 2006?
Your answer should be compact. 0.76. What is the ratio of the Domestic credit (% of GDP) of Tonga in 2002 to that in 2006?
Give a very brief answer. 0.91. What is the ratio of the Domestic credit (% of GDP) of Angola in 2002 to that in 2007?
Give a very brief answer. 0.35. What is the ratio of the Domestic credit (% of GDP) in Solomon Islands in 2002 to that in 2007?
Keep it short and to the point. 0.33. What is the ratio of the Domestic credit (% of GDP) of South Africa in 2002 to that in 2007?
Offer a terse response. 0.72. What is the ratio of the Domestic credit (% of GDP) of Tonga in 2002 to that in 2007?
Make the answer very short. 0.79. What is the ratio of the Domestic credit (% of GDP) of Angola in 2003 to that in 2004?
Your response must be concise. 0.9. What is the ratio of the Domestic credit (% of GDP) in Solomon Islands in 2003 to that in 2004?
Keep it short and to the point. 1.03. What is the ratio of the Domestic credit (% of GDP) in South Africa in 2003 to that in 2004?
Your response must be concise. 0.97. What is the ratio of the Domestic credit (% of GDP) in Tonga in 2003 to that in 2004?
Keep it short and to the point. 1.08. What is the ratio of the Domestic credit (% of GDP) of Angola in 2003 to that in 2005?
Make the answer very short. 0.95. What is the ratio of the Domestic credit (% of GDP) in Solomon Islands in 2003 to that in 2005?
Make the answer very short. 0.71. What is the ratio of the Domestic credit (% of GDP) in South Africa in 2003 to that in 2005?
Make the answer very short. 0.92. What is the ratio of the Domestic credit (% of GDP) in Tonga in 2003 to that in 2005?
Give a very brief answer. 0.83. What is the ratio of the Domestic credit (% of GDP) in Angola in 2003 to that in 2006?
Offer a terse response. 0.62. What is the ratio of the Domestic credit (% of GDP) in Solomon Islands in 2003 to that in 2006?
Offer a very short reply. 0.5. What is the ratio of the Domestic credit (% of GDP) in South Africa in 2003 to that in 2006?
Keep it short and to the point. 0.83. What is the ratio of the Domestic credit (% of GDP) in Tonga in 2003 to that in 2006?
Your answer should be very brief. 0.92. What is the ratio of the Domestic credit (% of GDP) of Angola in 2003 to that in 2007?
Keep it short and to the point. 0.41. What is the ratio of the Domestic credit (% of GDP) of Solomon Islands in 2003 to that in 2007?
Offer a very short reply. 0.37. What is the ratio of the Domestic credit (% of GDP) of South Africa in 2003 to that in 2007?
Your response must be concise. 0.78. What is the ratio of the Domestic credit (% of GDP) in Tonga in 2003 to that in 2007?
Give a very brief answer. 0.8. What is the ratio of the Domestic credit (% of GDP) of Angola in 2004 to that in 2005?
Offer a very short reply. 1.05. What is the ratio of the Domestic credit (% of GDP) of Solomon Islands in 2004 to that in 2005?
Offer a very short reply. 0.7. What is the ratio of the Domestic credit (% of GDP) of South Africa in 2004 to that in 2005?
Your answer should be very brief. 0.95. What is the ratio of the Domestic credit (% of GDP) of Tonga in 2004 to that in 2005?
Make the answer very short. 0.77. What is the ratio of the Domestic credit (% of GDP) in Angola in 2004 to that in 2006?
Your response must be concise. 0.68. What is the ratio of the Domestic credit (% of GDP) of Solomon Islands in 2004 to that in 2006?
Offer a terse response. 0.49. What is the ratio of the Domestic credit (% of GDP) in South Africa in 2004 to that in 2006?
Your answer should be very brief. 0.85. What is the ratio of the Domestic credit (% of GDP) in Tonga in 2004 to that in 2006?
Ensure brevity in your answer.  0.85. What is the ratio of the Domestic credit (% of GDP) of Angola in 2004 to that in 2007?
Your answer should be very brief. 0.45. What is the ratio of the Domestic credit (% of GDP) of Solomon Islands in 2004 to that in 2007?
Your answer should be very brief. 0.36. What is the ratio of the Domestic credit (% of GDP) of South Africa in 2004 to that in 2007?
Keep it short and to the point. 0.8. What is the ratio of the Domestic credit (% of GDP) in Tonga in 2004 to that in 2007?
Your answer should be compact. 0.74. What is the ratio of the Domestic credit (% of GDP) of Angola in 2005 to that in 2006?
Offer a terse response. 0.65. What is the ratio of the Domestic credit (% of GDP) in Solomon Islands in 2005 to that in 2006?
Provide a succinct answer. 0.7. What is the ratio of the Domestic credit (% of GDP) in South Africa in 2005 to that in 2006?
Give a very brief answer. 0.9. What is the ratio of the Domestic credit (% of GDP) in Tonga in 2005 to that in 2006?
Make the answer very short. 1.1. What is the ratio of the Domestic credit (% of GDP) in Angola in 2005 to that in 2007?
Your answer should be very brief. 0.43. What is the ratio of the Domestic credit (% of GDP) of Solomon Islands in 2005 to that in 2007?
Provide a succinct answer. 0.52. What is the ratio of the Domestic credit (% of GDP) in South Africa in 2005 to that in 2007?
Your answer should be compact. 0.84. What is the ratio of the Domestic credit (% of GDP) in Tonga in 2005 to that in 2007?
Make the answer very short. 0.96. What is the ratio of the Domestic credit (% of GDP) in Angola in 2006 to that in 2007?
Offer a terse response. 0.66. What is the ratio of the Domestic credit (% of GDP) in Solomon Islands in 2006 to that in 2007?
Make the answer very short. 0.74. What is the ratio of the Domestic credit (% of GDP) of South Africa in 2006 to that in 2007?
Provide a succinct answer. 0.94. What is the ratio of the Domestic credit (% of GDP) in Tonga in 2006 to that in 2007?
Provide a succinct answer. 0.87. What is the difference between the highest and the second highest Domestic credit (% of GDP) in Angola?
Offer a terse response. 3.35. What is the difference between the highest and the second highest Domestic credit (% of GDP) of Solomon Islands?
Ensure brevity in your answer.  6.63. What is the difference between the highest and the second highest Domestic credit (% of GDP) in South Africa?
Provide a succinct answer. 4.67. What is the difference between the highest and the second highest Domestic credit (% of GDP) of Tonga?
Ensure brevity in your answer.  2.42. What is the difference between the highest and the lowest Domestic credit (% of GDP) in Angola?
Make the answer very short. 6.34. What is the difference between the highest and the lowest Domestic credit (% of GDP) of Solomon Islands?
Provide a short and direct response. 17.15. What is the difference between the highest and the lowest Domestic credit (% of GDP) of South Africa?
Offer a very short reply. 22.26. What is the difference between the highest and the lowest Domestic credit (% of GDP) in Tonga?
Give a very brief answer. 14.64. 